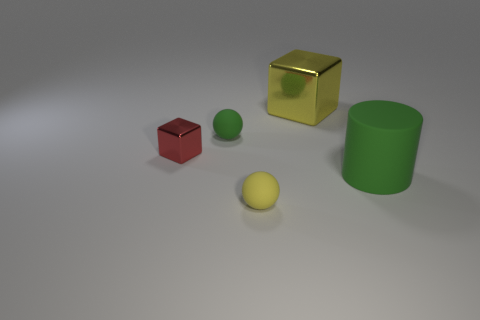Add 5 yellow rubber spheres. How many objects exist? 10 Subtract all spheres. How many objects are left? 3 Add 2 small yellow balls. How many small yellow balls are left? 3 Add 1 yellow matte balls. How many yellow matte balls exist? 2 Subtract 0 yellow cylinders. How many objects are left? 5 Subtract all large green things. Subtract all green things. How many objects are left? 2 